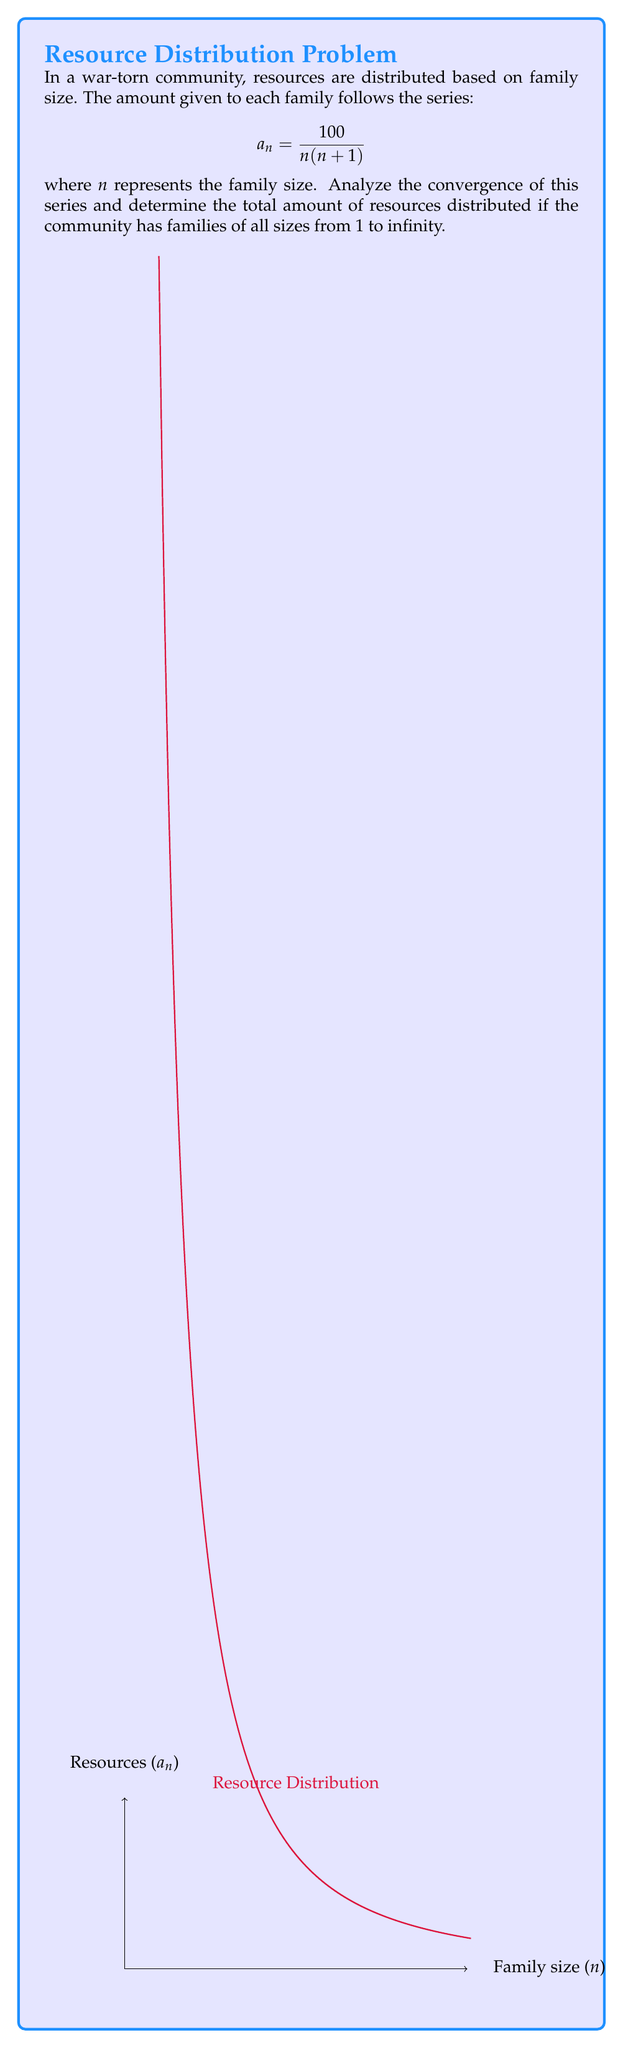Help me with this question. To analyze the convergence of this series, we'll use the comparison test with a p-series.

Step 1: Examine the general term of the series
$$a_n = \frac{100}{n(n+1)}$$

Step 2: Compare with a p-series
We can rewrite the term as:
$$a_n = \frac{100}{n(n+1)} = 100 \cdot \frac{1}{n} \cdot \frac{1}{n+1} < 100 \cdot \frac{1}{n} \cdot \frac{1}{n} = \frac{100}{n^2}$$

Step 3: Comparison test
Our series is term-by-term less than or equal to the series $\sum_{n=1}^{\infty} \frac{100}{n^2}$, which is a p-series with $p=2$.

Step 4: Determine convergence
Since $p > 1$, the comparison series converges. Therefore, our original series also converges.

Step 5: Calculate the sum
To find the exact sum, we can use the telescoping series method:

$$\begin{align}
\sum_{n=1}^{\infty} a_n &= \sum_{n=1}^{\infty} \frac{100}{n(n+1)} \\
&= 100 \sum_{n=1}^{\infty} (\frac{1}{n} - \frac{1}{n+1}) \\
&= 100 \lim_{N \to \infty} \sum_{n=1}^{N} (\frac{1}{n} - \frac{1}{n+1}) \\
&= 100 \lim_{N \to \infty} (1 - \frac{1}{2} + \frac{1}{2} - \frac{1}{3} + \frac{1}{3} - ... + \frac{1}{N} - \frac{1}{N+1}) \\
&= 100 \lim_{N \to \infty} (1 - \frac{1}{N+1}) \\
&= 100 \cdot 1 = 100
\end{align}$$

Therefore, the total amount of resources distributed is 100 units.
Answer: The series converges, and the sum is 100 units. 